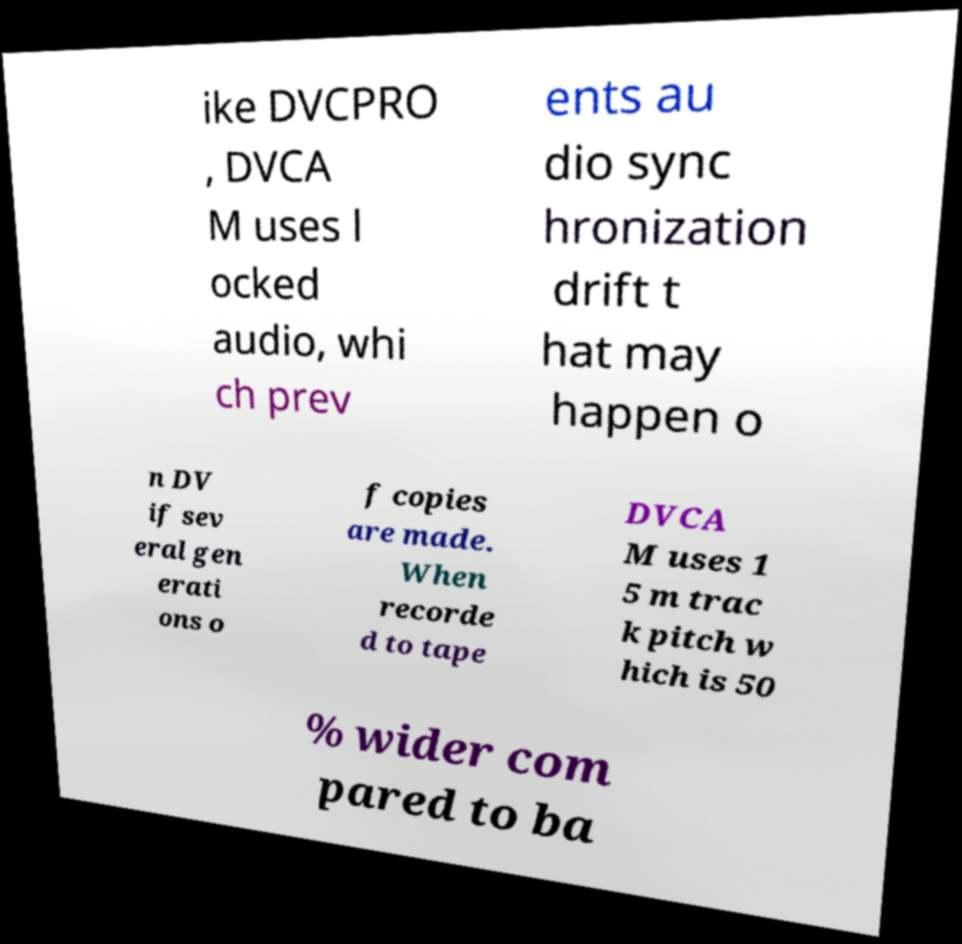Could you extract and type out the text from this image? ike DVCPRO , DVCA M uses l ocked audio, whi ch prev ents au dio sync hronization drift t hat may happen o n DV if sev eral gen erati ons o f copies are made. When recorde d to tape DVCA M uses 1 5 m trac k pitch w hich is 50 % wider com pared to ba 